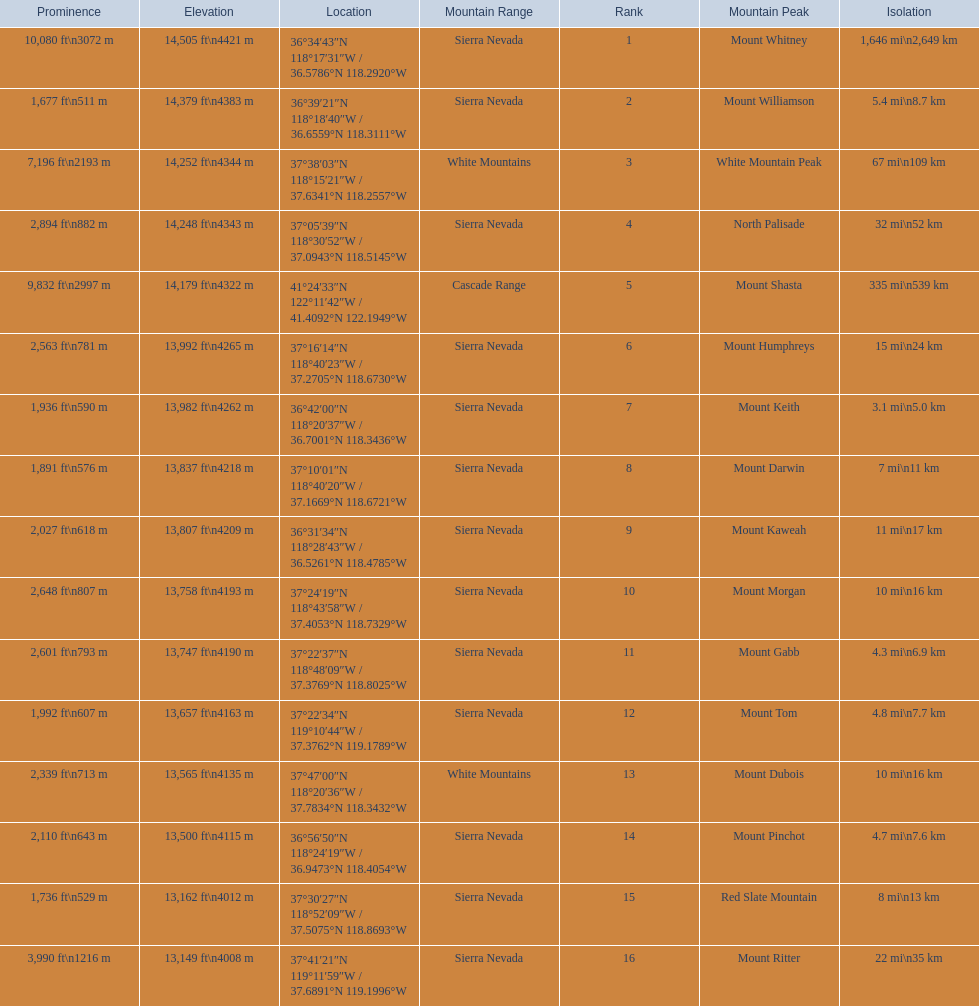What are the mountain peaks? Mount Whitney, Mount Williamson, White Mountain Peak, North Palisade, Mount Shasta, Mount Humphreys, Mount Keith, Mount Darwin, Mount Kaweah, Mount Morgan, Mount Gabb, Mount Tom, Mount Dubois, Mount Pinchot, Red Slate Mountain, Mount Ritter. Of these, which one has a prominence more than 10,000 ft? Mount Whitney. 